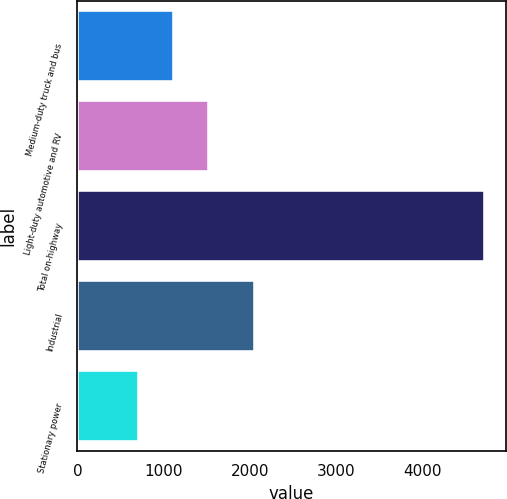Convert chart. <chart><loc_0><loc_0><loc_500><loc_500><bar_chart><fcel>Medium-duty truck and bus<fcel>Light-duty automotive and RV<fcel>Total on-highway<fcel>Industrial<fcel>Stationary power<nl><fcel>1119.2<fcel>1520.4<fcel>4730<fcel>2063<fcel>718<nl></chart> 